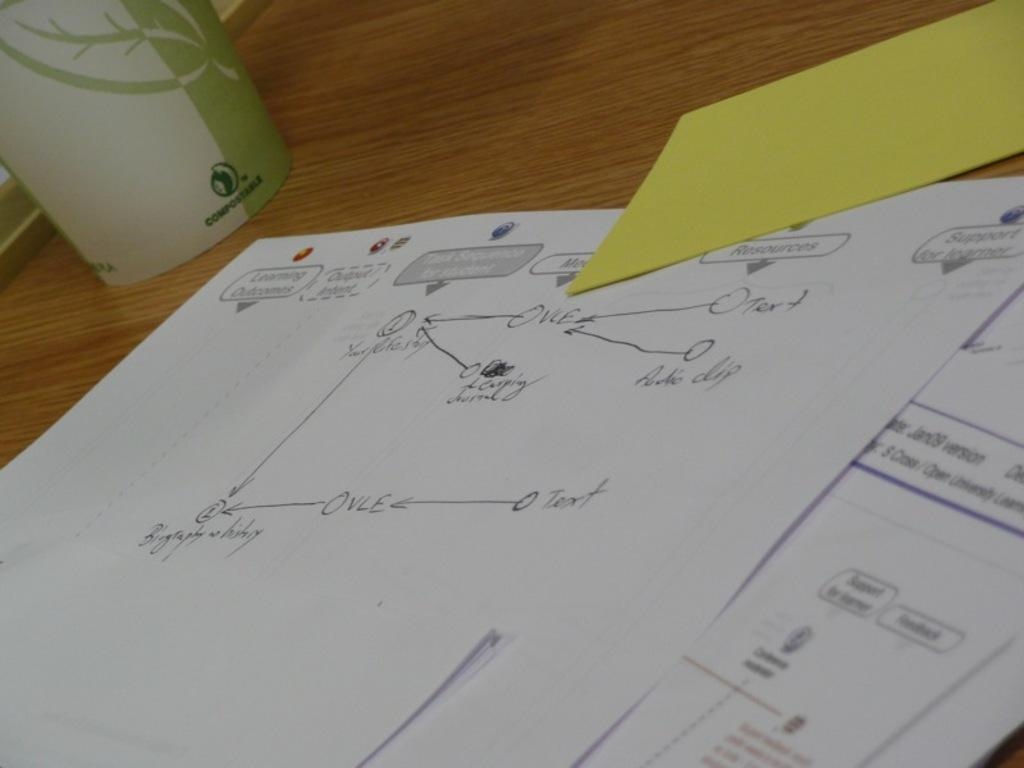<image>
Create a compact narrative representing the image presented. papers on desk with the letters OVLE on it in several places and a green and white cup in the background and also a blank yellow card 